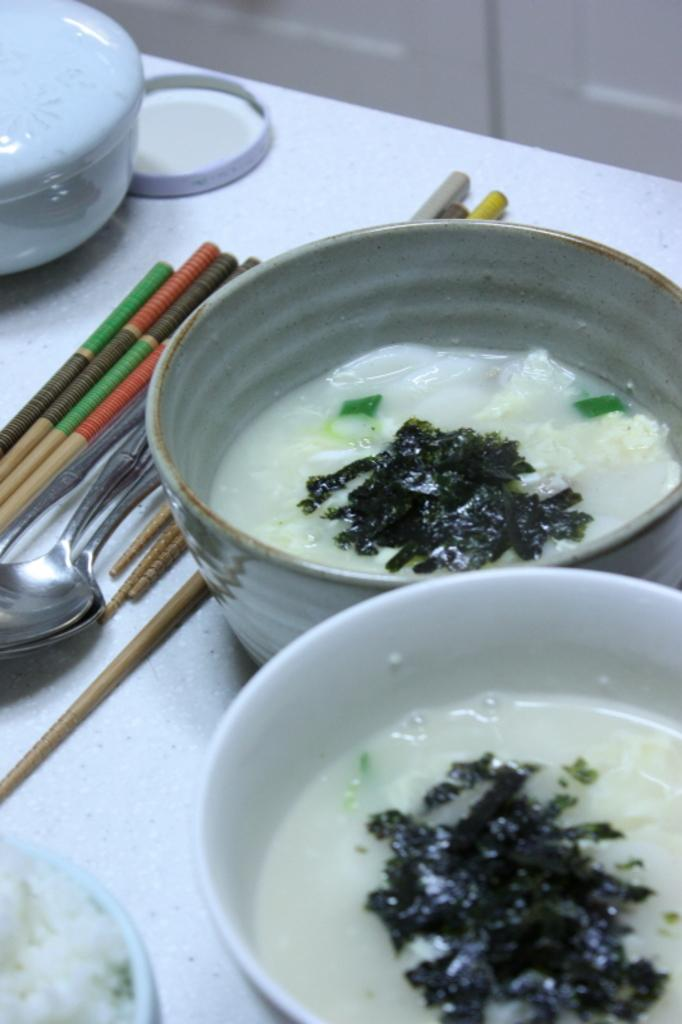What type of food items can be seen in the image? There are food items in bowls in the image. What utensils are present in the image? Spoons are visible in the image. What else can be seen on the table in the image? There are other objects on the table in the image. What type of lace is used to decorate the park in the image? There is no park or lace present in the image. What color are the crayons on the table in the image? There are no crayons present in the image. 